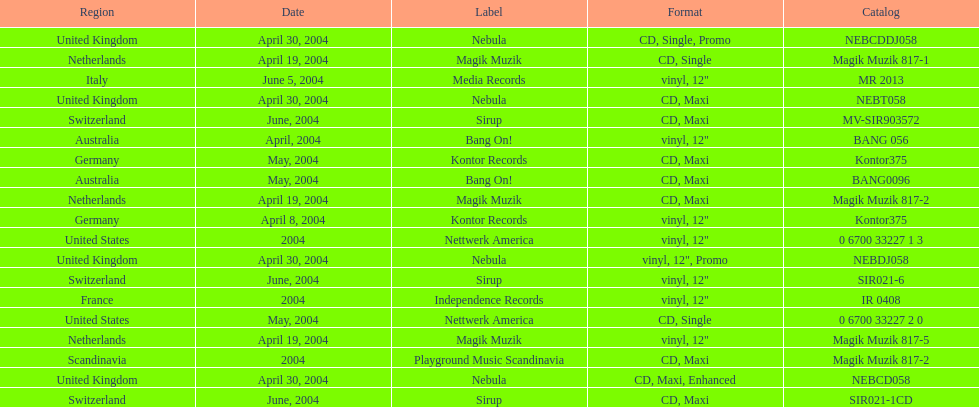What label was italy on? Media Records. 